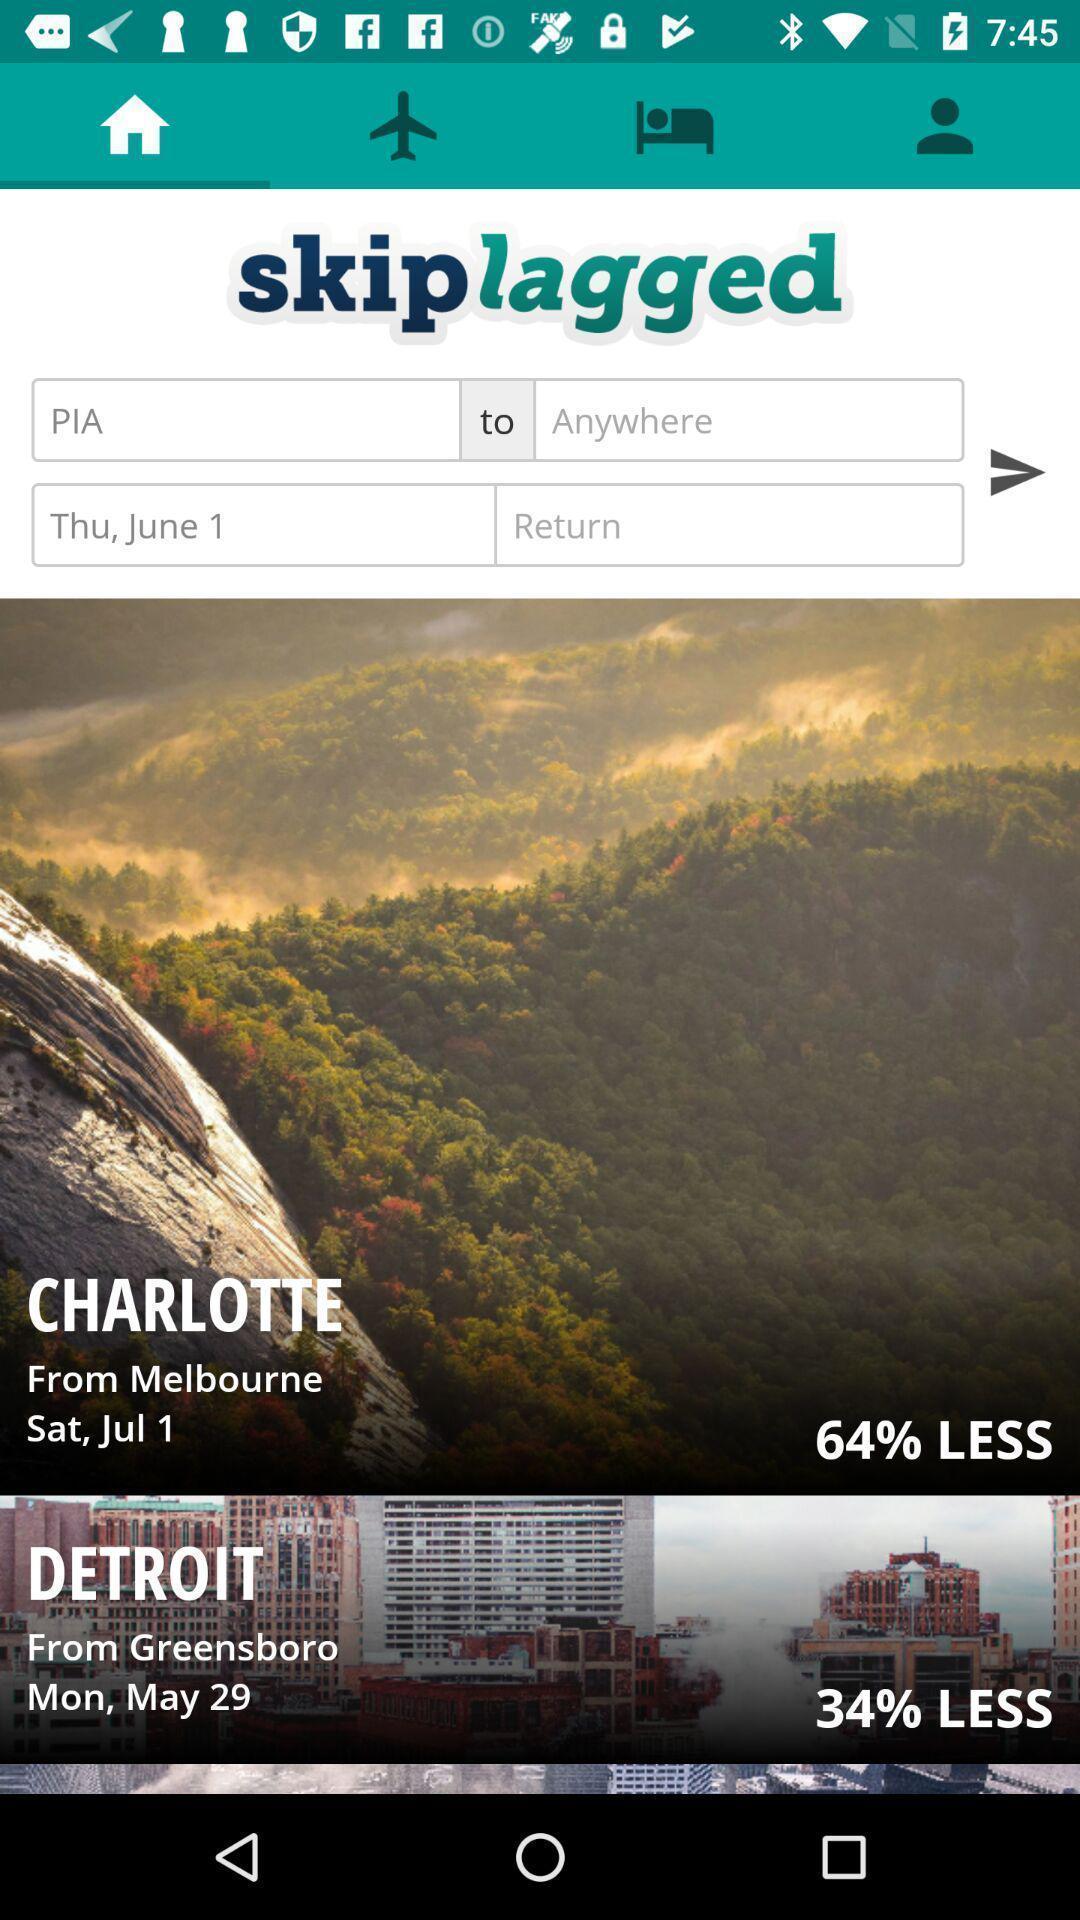Tell me about the visual elements in this screen capture. Page showing options related to a travel based app. 